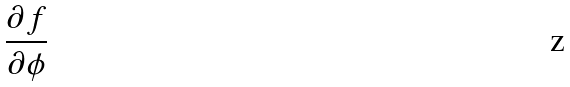Convert formula to latex. <formula><loc_0><loc_0><loc_500><loc_500>\frac { \partial f } { \partial \phi }</formula> 